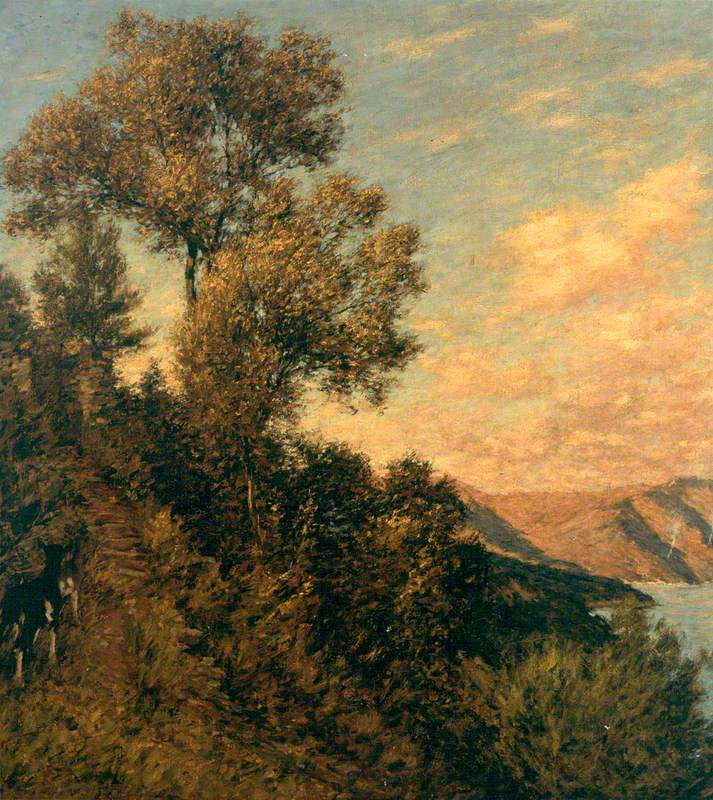Can you speculate on the time of day this scene might depict? The luminous quality of the sky, with its gradients of orange and pale blue, suggests the painting depicts either early morning or late afternoon, during the 'golden hour' when the sun is low on the horizon. The warm light typically associated with this time of day bathes the scene in a soft glow, adding to the painting's tranquil ambiance. 